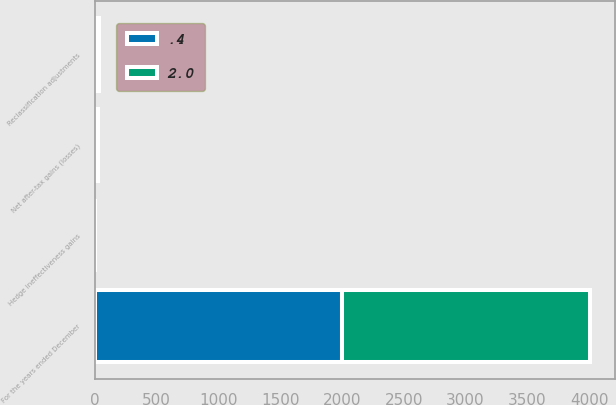<chart> <loc_0><loc_0><loc_500><loc_500><stacked_bar_chart><ecel><fcel>For the years ended December<fcel>Net after-tax gains (losses)<fcel>Reclassification adjustments<fcel>Hedge ineffectiveness gains<nl><fcel>2<fcel>2006<fcel>11.4<fcel>5.3<fcel>2<nl><fcel>0.4<fcel>2004<fcel>16.3<fcel>26.1<fcel>0.4<nl></chart> 